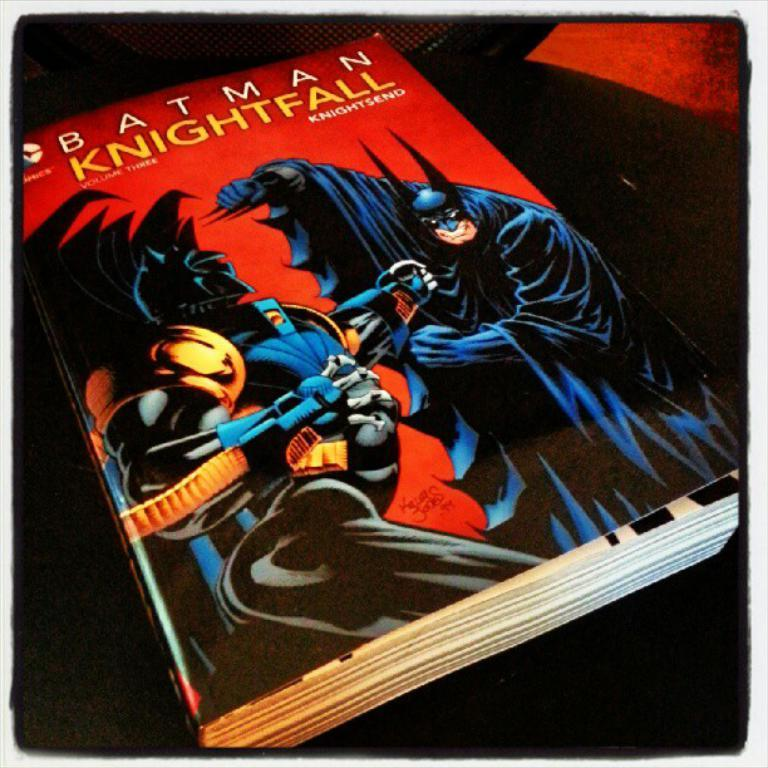<image>
Create a compact narrative representing the image presented. A large book titled Batman Knightfall with Batman on the front cover 